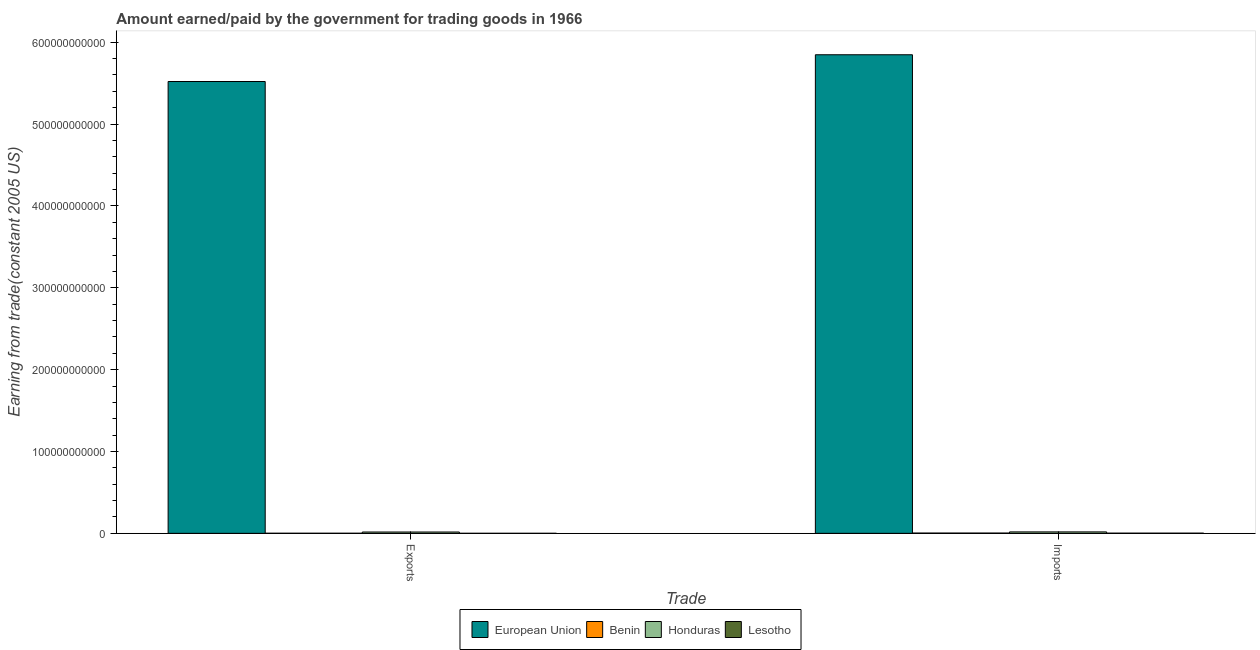How many different coloured bars are there?
Keep it short and to the point. 4. How many groups of bars are there?
Your answer should be compact. 2. What is the label of the 1st group of bars from the left?
Your response must be concise. Exports. What is the amount paid for imports in Benin?
Provide a short and direct response. 3.23e+08. Across all countries, what is the maximum amount earned from exports?
Give a very brief answer. 5.52e+11. Across all countries, what is the minimum amount earned from exports?
Your answer should be compact. 1.50e+07. In which country was the amount earned from exports minimum?
Your answer should be compact. Lesotho. What is the total amount paid for imports in the graph?
Provide a succinct answer. 5.87e+11. What is the difference between the amount earned from exports in Benin and that in European Union?
Make the answer very short. -5.52e+11. What is the difference between the amount paid for imports in Lesotho and the amount earned from exports in European Union?
Your answer should be very brief. -5.52e+11. What is the average amount earned from exports per country?
Offer a terse response. 1.38e+11. What is the difference between the amount earned from exports and amount paid for imports in Honduras?
Provide a short and direct response. -1.51e+08. What is the ratio of the amount paid for imports in Lesotho to that in Benin?
Offer a terse response. 0.63. What does the 2nd bar from the left in Exports represents?
Provide a succinct answer. Benin. What does the 3rd bar from the right in Exports represents?
Your answer should be compact. Benin. How many bars are there?
Offer a terse response. 8. Are all the bars in the graph horizontal?
Offer a very short reply. No. What is the difference between two consecutive major ticks on the Y-axis?
Provide a short and direct response. 1.00e+11. Does the graph contain any zero values?
Offer a terse response. No. Does the graph contain grids?
Offer a terse response. No. Where does the legend appear in the graph?
Offer a terse response. Bottom center. How many legend labels are there?
Offer a terse response. 4. How are the legend labels stacked?
Offer a terse response. Horizontal. What is the title of the graph?
Your answer should be very brief. Amount earned/paid by the government for trading goods in 1966. Does "Germany" appear as one of the legend labels in the graph?
Offer a very short reply. No. What is the label or title of the X-axis?
Give a very brief answer. Trade. What is the label or title of the Y-axis?
Provide a succinct answer. Earning from trade(constant 2005 US). What is the Earning from trade(constant 2005 US) of European Union in Exports?
Give a very brief answer. 5.52e+11. What is the Earning from trade(constant 2005 US) in Benin in Exports?
Your answer should be compact. 8.54e+07. What is the Earning from trade(constant 2005 US) in Honduras in Exports?
Make the answer very short. 1.61e+09. What is the Earning from trade(constant 2005 US) of Lesotho in Exports?
Give a very brief answer. 1.50e+07. What is the Earning from trade(constant 2005 US) of European Union in Imports?
Ensure brevity in your answer.  5.85e+11. What is the Earning from trade(constant 2005 US) in Benin in Imports?
Offer a terse response. 3.23e+08. What is the Earning from trade(constant 2005 US) of Honduras in Imports?
Provide a succinct answer. 1.76e+09. What is the Earning from trade(constant 2005 US) in Lesotho in Imports?
Keep it short and to the point. 2.03e+08. Across all Trade, what is the maximum Earning from trade(constant 2005 US) in European Union?
Keep it short and to the point. 5.85e+11. Across all Trade, what is the maximum Earning from trade(constant 2005 US) of Benin?
Your answer should be compact. 3.23e+08. Across all Trade, what is the maximum Earning from trade(constant 2005 US) of Honduras?
Give a very brief answer. 1.76e+09. Across all Trade, what is the maximum Earning from trade(constant 2005 US) in Lesotho?
Ensure brevity in your answer.  2.03e+08. Across all Trade, what is the minimum Earning from trade(constant 2005 US) in European Union?
Offer a terse response. 5.52e+11. Across all Trade, what is the minimum Earning from trade(constant 2005 US) of Benin?
Your answer should be very brief. 8.54e+07. Across all Trade, what is the minimum Earning from trade(constant 2005 US) in Honduras?
Keep it short and to the point. 1.61e+09. Across all Trade, what is the minimum Earning from trade(constant 2005 US) of Lesotho?
Your response must be concise. 1.50e+07. What is the total Earning from trade(constant 2005 US) in European Union in the graph?
Your response must be concise. 1.14e+12. What is the total Earning from trade(constant 2005 US) in Benin in the graph?
Give a very brief answer. 4.08e+08. What is the total Earning from trade(constant 2005 US) in Honduras in the graph?
Provide a succinct answer. 3.37e+09. What is the total Earning from trade(constant 2005 US) of Lesotho in the graph?
Your response must be concise. 2.18e+08. What is the difference between the Earning from trade(constant 2005 US) of European Union in Exports and that in Imports?
Make the answer very short. -3.27e+1. What is the difference between the Earning from trade(constant 2005 US) of Benin in Exports and that in Imports?
Give a very brief answer. -2.37e+08. What is the difference between the Earning from trade(constant 2005 US) in Honduras in Exports and that in Imports?
Offer a terse response. -1.51e+08. What is the difference between the Earning from trade(constant 2005 US) of Lesotho in Exports and that in Imports?
Offer a very short reply. -1.88e+08. What is the difference between the Earning from trade(constant 2005 US) in European Union in Exports and the Earning from trade(constant 2005 US) in Benin in Imports?
Your answer should be compact. 5.52e+11. What is the difference between the Earning from trade(constant 2005 US) of European Union in Exports and the Earning from trade(constant 2005 US) of Honduras in Imports?
Offer a very short reply. 5.50e+11. What is the difference between the Earning from trade(constant 2005 US) of European Union in Exports and the Earning from trade(constant 2005 US) of Lesotho in Imports?
Your response must be concise. 5.52e+11. What is the difference between the Earning from trade(constant 2005 US) of Benin in Exports and the Earning from trade(constant 2005 US) of Honduras in Imports?
Your answer should be very brief. -1.68e+09. What is the difference between the Earning from trade(constant 2005 US) in Benin in Exports and the Earning from trade(constant 2005 US) in Lesotho in Imports?
Give a very brief answer. -1.17e+08. What is the difference between the Earning from trade(constant 2005 US) of Honduras in Exports and the Earning from trade(constant 2005 US) of Lesotho in Imports?
Your response must be concise. 1.41e+09. What is the average Earning from trade(constant 2005 US) in European Union per Trade?
Offer a terse response. 5.68e+11. What is the average Earning from trade(constant 2005 US) in Benin per Trade?
Your answer should be very brief. 2.04e+08. What is the average Earning from trade(constant 2005 US) in Honduras per Trade?
Offer a terse response. 1.69e+09. What is the average Earning from trade(constant 2005 US) of Lesotho per Trade?
Provide a short and direct response. 1.09e+08. What is the difference between the Earning from trade(constant 2005 US) in European Union and Earning from trade(constant 2005 US) in Benin in Exports?
Give a very brief answer. 5.52e+11. What is the difference between the Earning from trade(constant 2005 US) of European Union and Earning from trade(constant 2005 US) of Honduras in Exports?
Make the answer very short. 5.50e+11. What is the difference between the Earning from trade(constant 2005 US) of European Union and Earning from trade(constant 2005 US) of Lesotho in Exports?
Ensure brevity in your answer.  5.52e+11. What is the difference between the Earning from trade(constant 2005 US) in Benin and Earning from trade(constant 2005 US) in Honduras in Exports?
Offer a very short reply. -1.52e+09. What is the difference between the Earning from trade(constant 2005 US) in Benin and Earning from trade(constant 2005 US) in Lesotho in Exports?
Make the answer very short. 7.04e+07. What is the difference between the Earning from trade(constant 2005 US) in Honduras and Earning from trade(constant 2005 US) in Lesotho in Exports?
Your answer should be compact. 1.59e+09. What is the difference between the Earning from trade(constant 2005 US) of European Union and Earning from trade(constant 2005 US) of Benin in Imports?
Ensure brevity in your answer.  5.84e+11. What is the difference between the Earning from trade(constant 2005 US) of European Union and Earning from trade(constant 2005 US) of Honduras in Imports?
Make the answer very short. 5.83e+11. What is the difference between the Earning from trade(constant 2005 US) of European Union and Earning from trade(constant 2005 US) of Lesotho in Imports?
Your response must be concise. 5.85e+11. What is the difference between the Earning from trade(constant 2005 US) of Benin and Earning from trade(constant 2005 US) of Honduras in Imports?
Provide a succinct answer. -1.44e+09. What is the difference between the Earning from trade(constant 2005 US) of Benin and Earning from trade(constant 2005 US) of Lesotho in Imports?
Offer a terse response. 1.20e+08. What is the difference between the Earning from trade(constant 2005 US) of Honduras and Earning from trade(constant 2005 US) of Lesotho in Imports?
Provide a short and direct response. 1.56e+09. What is the ratio of the Earning from trade(constant 2005 US) in European Union in Exports to that in Imports?
Your answer should be compact. 0.94. What is the ratio of the Earning from trade(constant 2005 US) of Benin in Exports to that in Imports?
Keep it short and to the point. 0.26. What is the ratio of the Earning from trade(constant 2005 US) of Honduras in Exports to that in Imports?
Make the answer very short. 0.91. What is the ratio of the Earning from trade(constant 2005 US) in Lesotho in Exports to that in Imports?
Your answer should be very brief. 0.07. What is the difference between the highest and the second highest Earning from trade(constant 2005 US) of European Union?
Offer a very short reply. 3.27e+1. What is the difference between the highest and the second highest Earning from trade(constant 2005 US) in Benin?
Provide a succinct answer. 2.37e+08. What is the difference between the highest and the second highest Earning from trade(constant 2005 US) of Honduras?
Your response must be concise. 1.51e+08. What is the difference between the highest and the second highest Earning from trade(constant 2005 US) of Lesotho?
Make the answer very short. 1.88e+08. What is the difference between the highest and the lowest Earning from trade(constant 2005 US) in European Union?
Keep it short and to the point. 3.27e+1. What is the difference between the highest and the lowest Earning from trade(constant 2005 US) in Benin?
Offer a very short reply. 2.37e+08. What is the difference between the highest and the lowest Earning from trade(constant 2005 US) of Honduras?
Offer a very short reply. 1.51e+08. What is the difference between the highest and the lowest Earning from trade(constant 2005 US) of Lesotho?
Ensure brevity in your answer.  1.88e+08. 